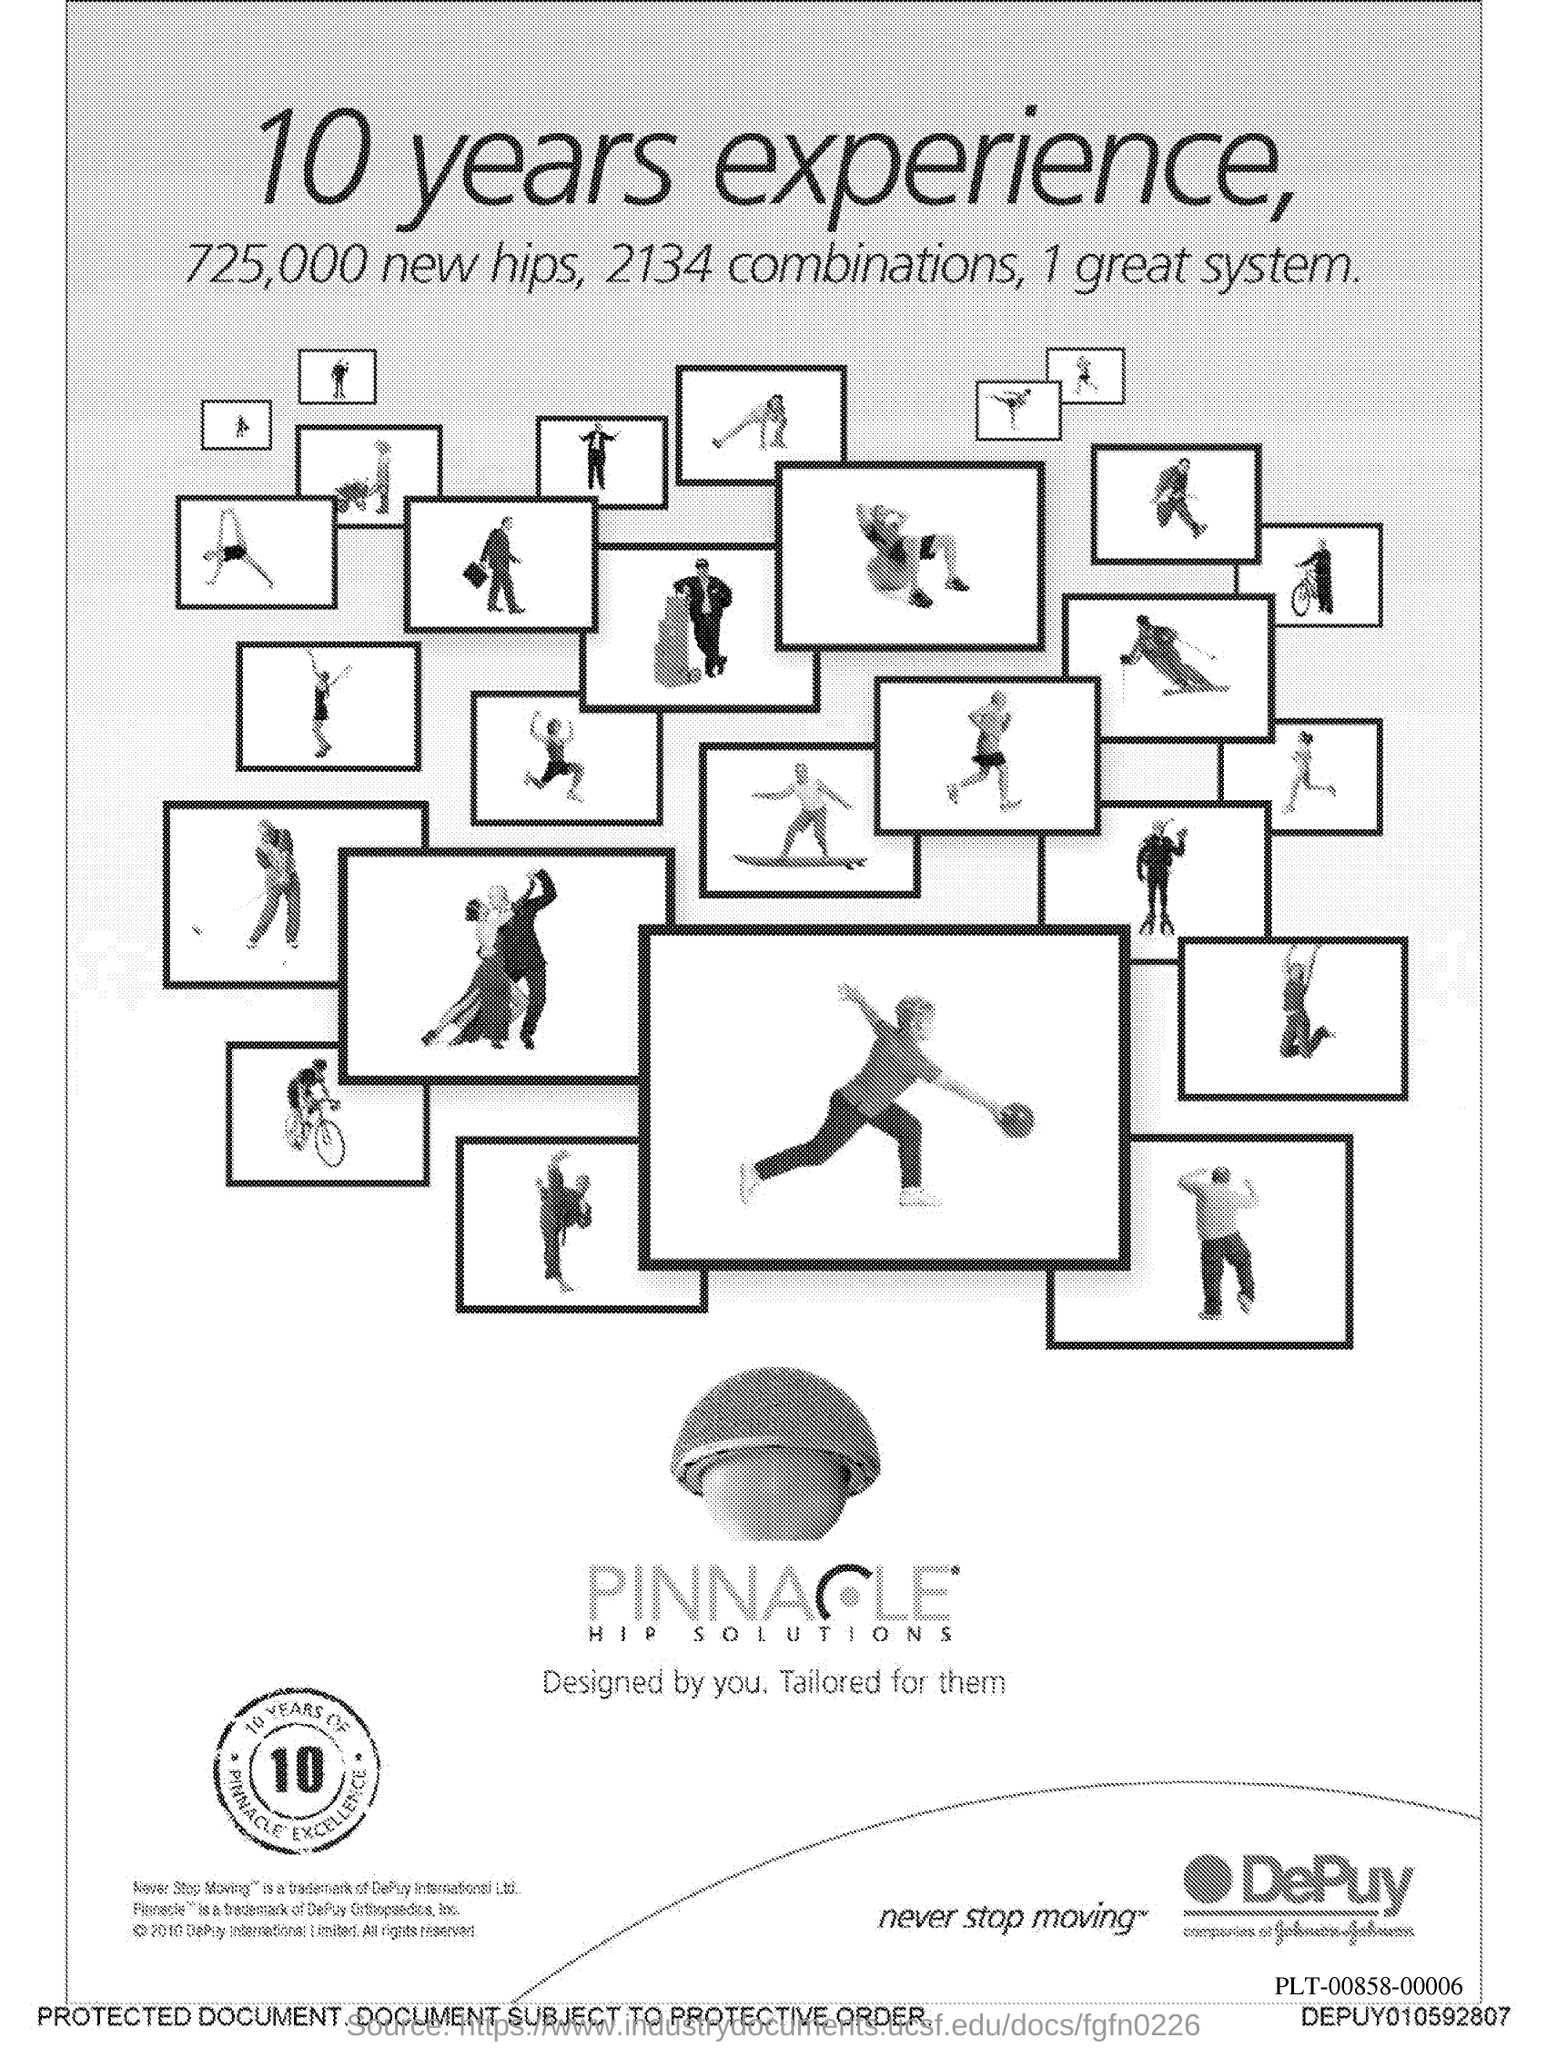What is the number in the zeal?
Give a very brief answer. 10. 